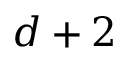<formula> <loc_0><loc_0><loc_500><loc_500>d + 2</formula> 